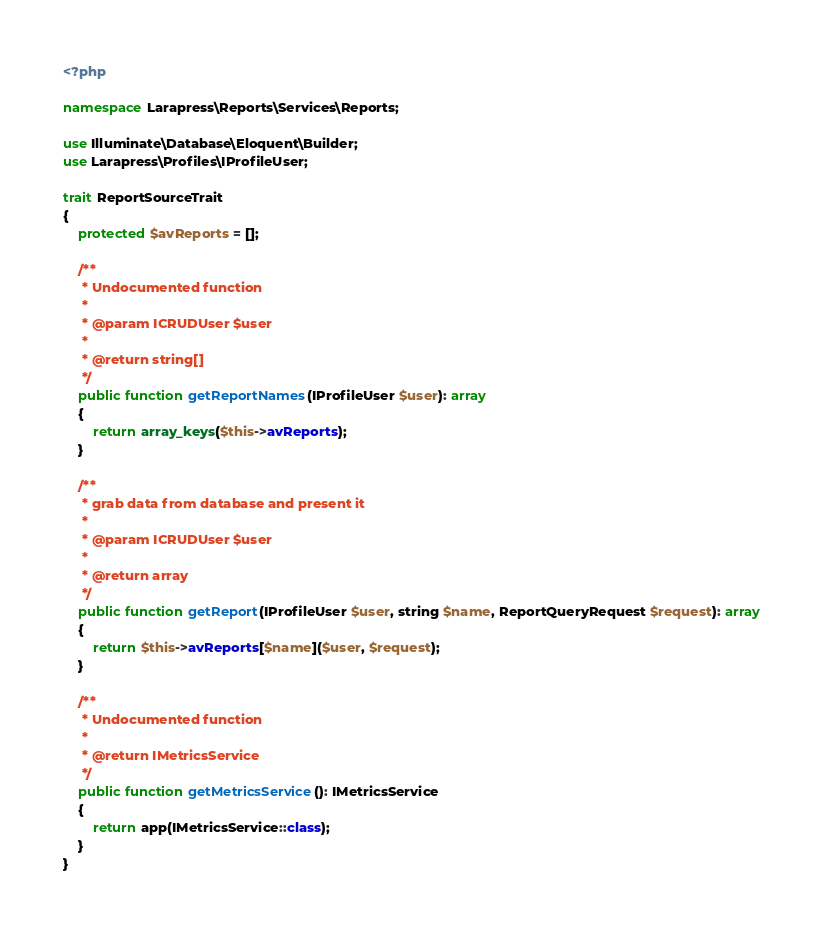<code> <loc_0><loc_0><loc_500><loc_500><_PHP_><?php

namespace Larapress\Reports\Services\Reports;

use Illuminate\Database\Eloquent\Builder;
use Larapress\Profiles\IProfileUser;

trait ReportSourceTrait
{
    protected $avReports = [];

    /**
     * Undocumented function
     *
     * @param ICRUDUser $user
     *
     * @return string[]
     */
    public function getReportNames(IProfileUser $user): array
    {
        return array_keys($this->avReports);
    }

    /**
     * grab data from database and present it
     *
     * @param ICRUDUser $user
     *
     * @return array
     */
    public function getReport(IProfileUser $user, string $name, ReportQueryRequest $request): array
    {
        return $this->avReports[$name]($user, $request);
    }

    /**
     * Undocumented function
     *
     * @return IMetricsService
     */
    public function getMetricsService(): IMetricsService
    {
        return app(IMetricsService::class);
    }
}
</code> 